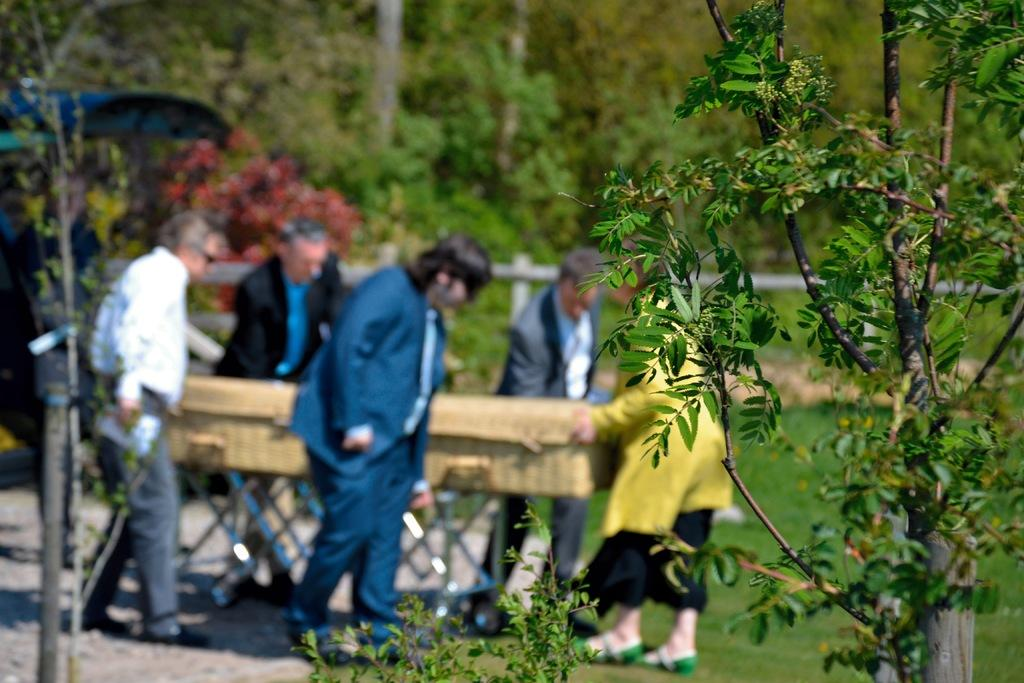How many people are in the image? There is a group of people in the image, but the exact number is not specified. What is the position of the people in the image? The people are standing on the ground in the image. What object can be seen in the image besides the people? There is a box in the image. What type of vegetation is present in the image? There is grass in the image. What can be seen in the background of the image? There are trees in the background of the image. Who is wearing the crown in the image? There is no crown present in the image. How does the blade of grass move during the rainstorm in the image? There is no rainstorm present in the image, and therefore no movement of the grass can be observed. 